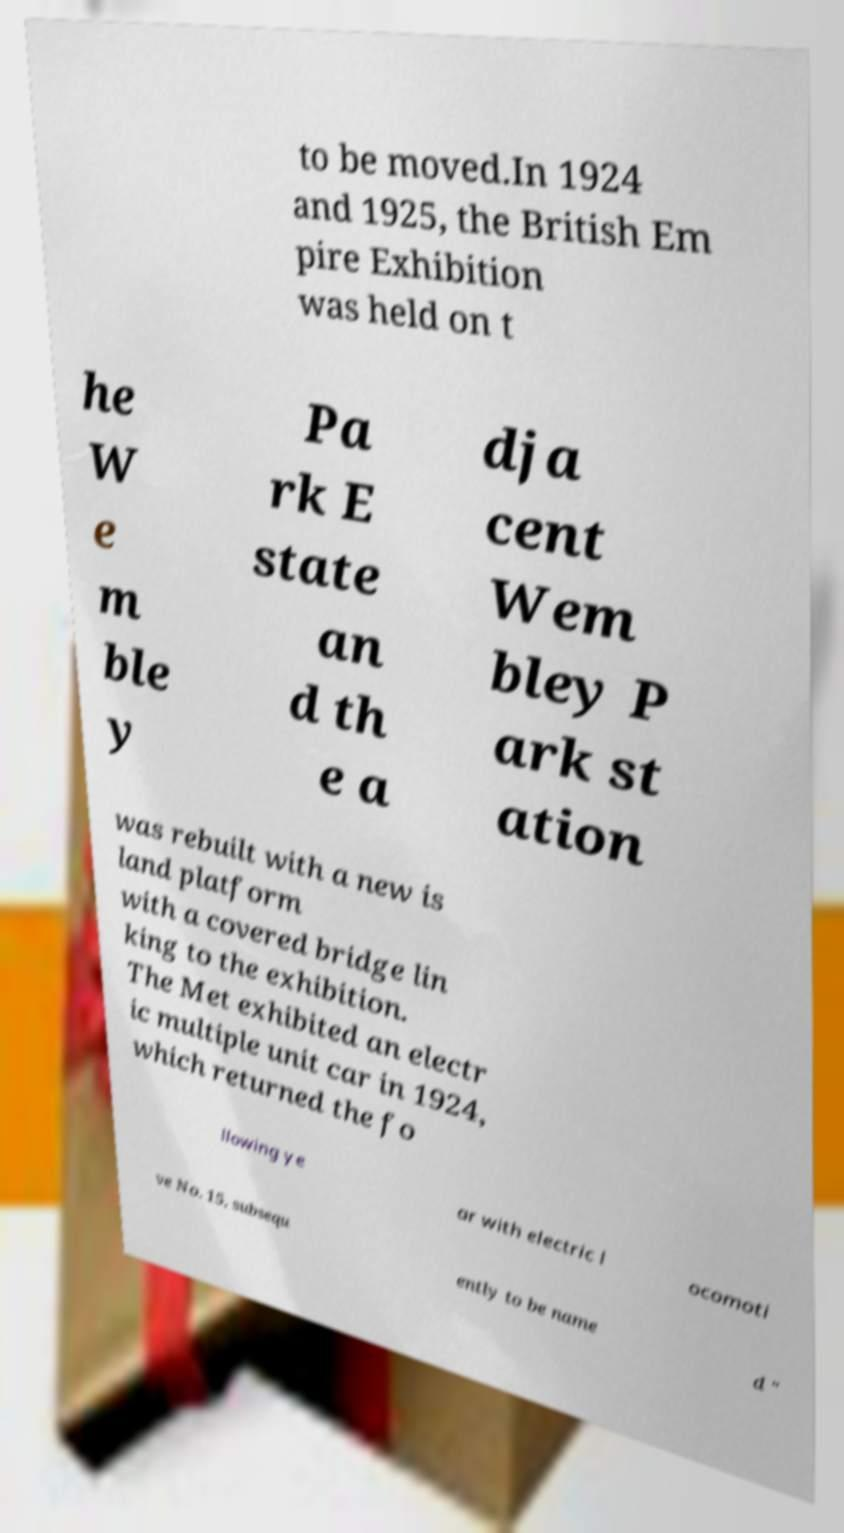What messages or text are displayed in this image? I need them in a readable, typed format. to be moved.In 1924 and 1925, the British Em pire Exhibition was held on t he W e m ble y Pa rk E state an d th e a dja cent Wem bley P ark st ation was rebuilt with a new is land platform with a covered bridge lin king to the exhibition. The Met exhibited an electr ic multiple unit car in 1924, which returned the fo llowing ye ar with electric l ocomoti ve No. 15, subsequ ently to be name d " 